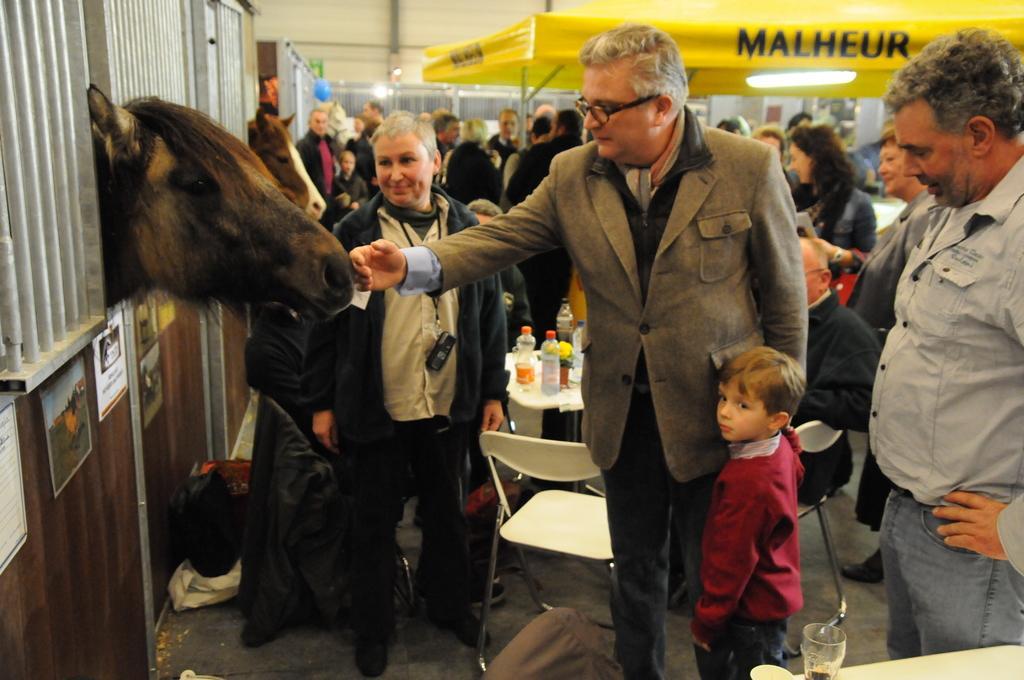Please provide a concise description of this image. In this picture, we see two horses. This picture might be clicked in the stable. The man in the blazer is touching the horse with his hand. Beside him, the boy in the red jacket is standing. Beside him, the man in black jacket is smiling. On the right side, we see a man in grey shirt is standing and he is looking at the boy. Behind them, we see the chairs and a table on which bottles are placed. In the right bottom of the picture, we see a white table on which a glass containing liquid is placed. There are people standing under the yellow tent. In the background, we see a white wall. 